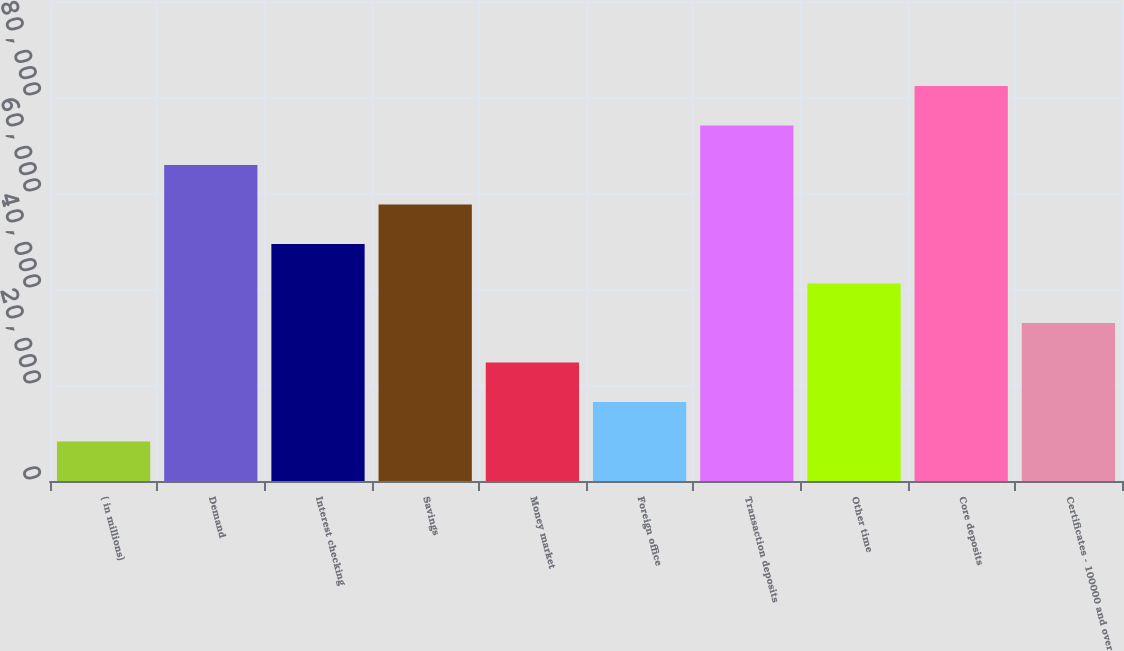Convert chart to OTSL. <chart><loc_0><loc_0><loc_500><loc_500><bar_chart><fcel>( in millions)<fcel>Demand<fcel>Interest checking<fcel>Savings<fcel>Money market<fcel>Foreign office<fcel>Transaction deposits<fcel>Other time<fcel>Core deposits<fcel>Certificates - 100000 and over<nl><fcel>8233.1<fcel>65822.8<fcel>49368.6<fcel>57595.7<fcel>24687.3<fcel>16460.2<fcel>74049.9<fcel>41141.5<fcel>82277<fcel>32914.4<nl></chart> 